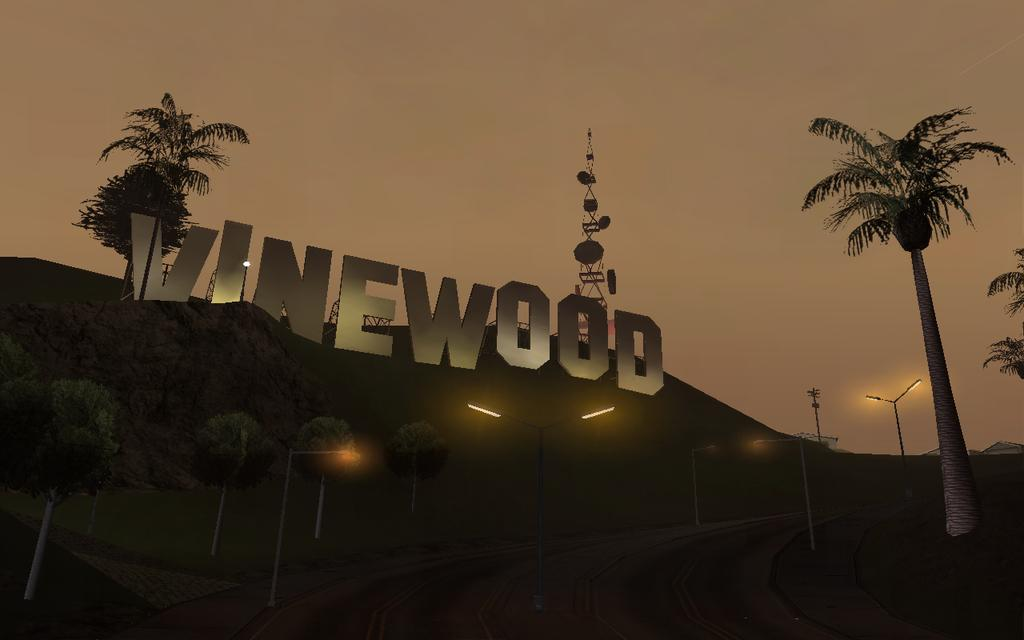What type of landscape feature is present in the image? There is a hill in the image. What can be found on the hill? There are trees and a tower on the hill. What type of lighting is present in the image? There are pole lights in the image. What type of text is present in the image? There is large size text in the image. What is the condition of the sky in the image? The sky is cloudy in the image. What is the chance of winning a stage in the image? There is no stage or competition present in the image, so it's not possible to determine the chance of winning anything. What type of hammer is being used to construct the tower in the image? There is no hammer or construction activity present in the image; it features a hill with trees, a tower, pole lights, and text. 